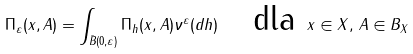<formula> <loc_0><loc_0><loc_500><loc_500>\Pi _ { \varepsilon } ( x , A ) = \int _ { \bar { B } ( 0 , \varepsilon ) } \Pi _ { h } ( x , A ) \nu ^ { \varepsilon } ( d h ) \quad \text {dla } x \in X , \, A \in B _ { X }</formula> 